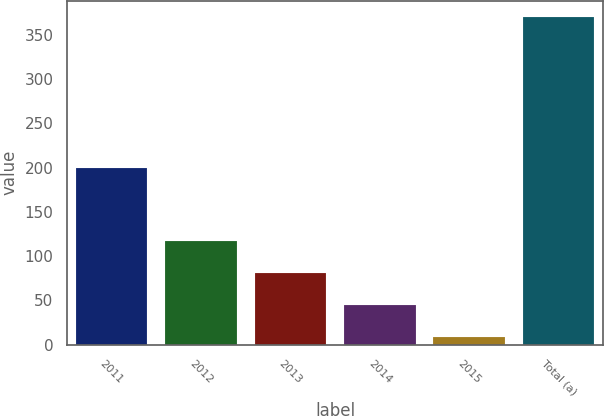<chart> <loc_0><loc_0><loc_500><loc_500><bar_chart><fcel>2011<fcel>2012<fcel>2013<fcel>2014<fcel>2015<fcel>Total (a)<nl><fcel>200<fcel>117.3<fcel>81.2<fcel>45.1<fcel>9<fcel>370<nl></chart> 